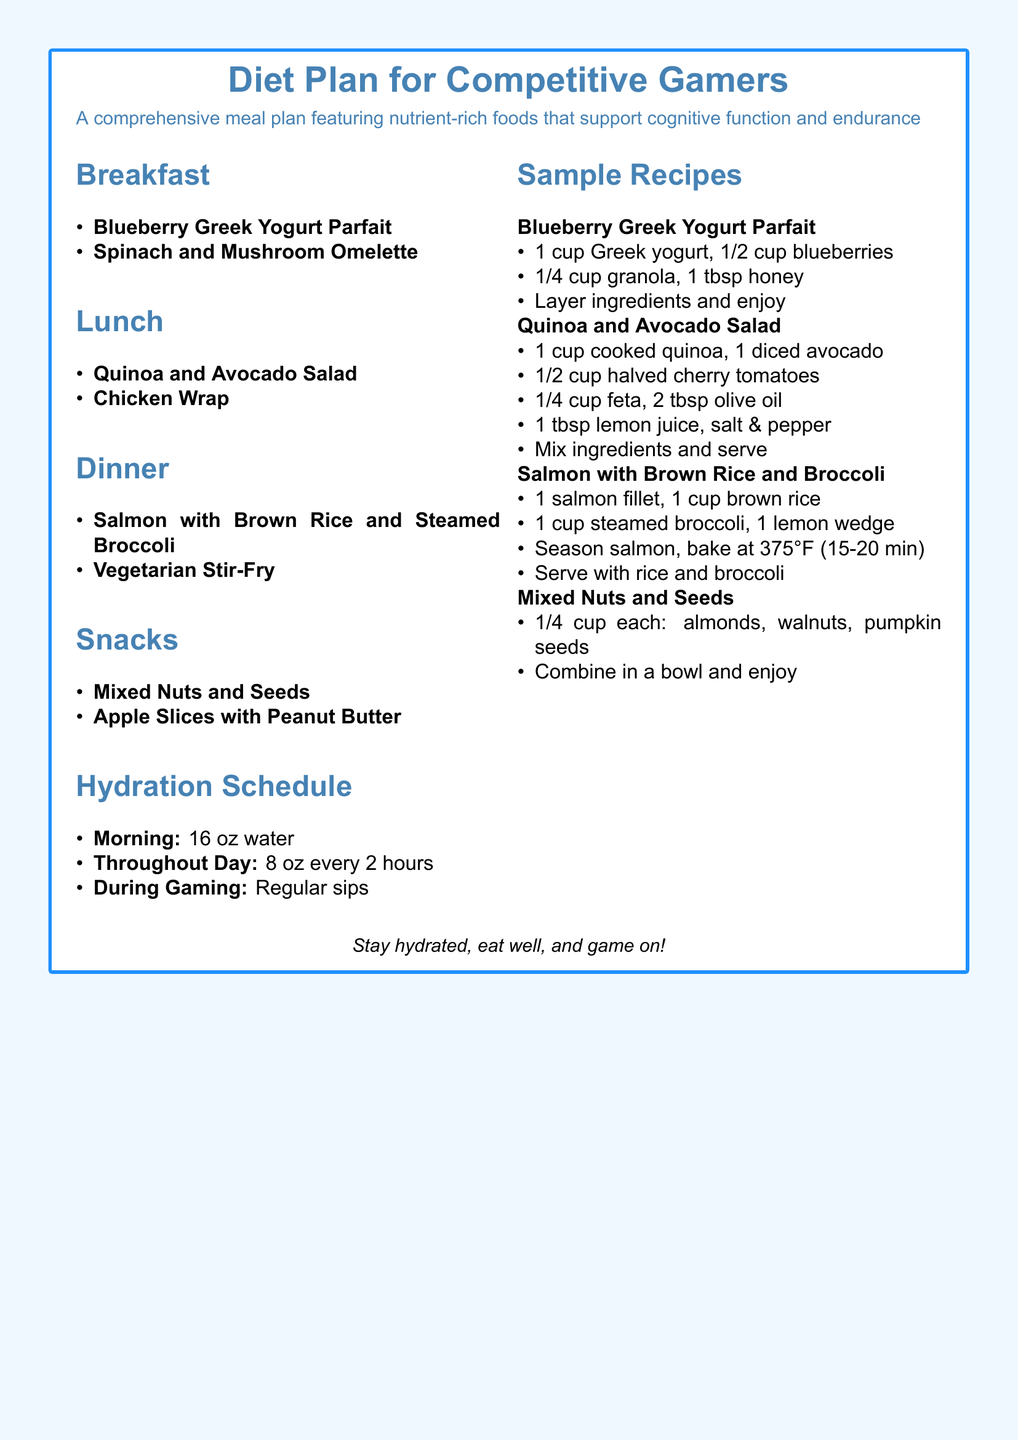What is the main focus of the diet plan? The diet plan focuses on nutrient-rich foods that support cognitive function and endurance, specifically for competitive gamers.
Answer: cognitive function and endurance How many meals are included in the meal plan? The meal plan includes breakfast, lunch, dinner, and snacks, totaling four meal categories.
Answer: four What is one of the breakfast options listed? The document lists a Blueberry Greek Yogurt Parfait as one of the breakfast options.
Answer: Blueberry Greek Yogurt Parfait How much water should be consumed in the morning? The hydration schedule states that 16 oz of water should be consumed in the morning.
Answer: 16 oz What ingredient is used in the Quinoa and Avocado Salad? The salad includes cooked quinoa as one of its key ingredients.
Answer: cooked quinoa What is a snack option provided in the document? The document lists Mixed Nuts and Seeds as a snack option.
Answer: Mixed Nuts and Seeds What cooking method is suggested for the salmon? The document suggests baking the salmon at 375°F as the cooking method.
Answer: baking at 375°F What should be combined to enjoy the Mixed Nuts and Seeds? The bowl should contain 1/4 cup each of almonds, walnuts, and pumpkin seeds as the ingredients to enjoy.
Answer: almonds, walnuts, pumpkin seeds 